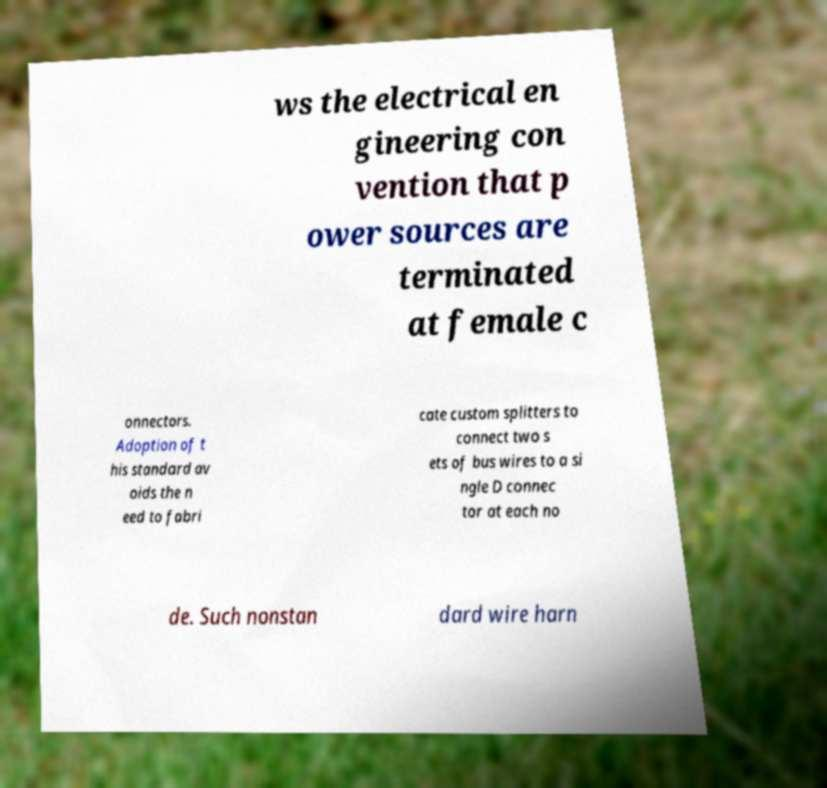What messages or text are displayed in this image? I need them in a readable, typed format. ws the electrical en gineering con vention that p ower sources are terminated at female c onnectors. Adoption of t his standard av oids the n eed to fabri cate custom splitters to connect two s ets of bus wires to a si ngle D connec tor at each no de. Such nonstan dard wire harn 